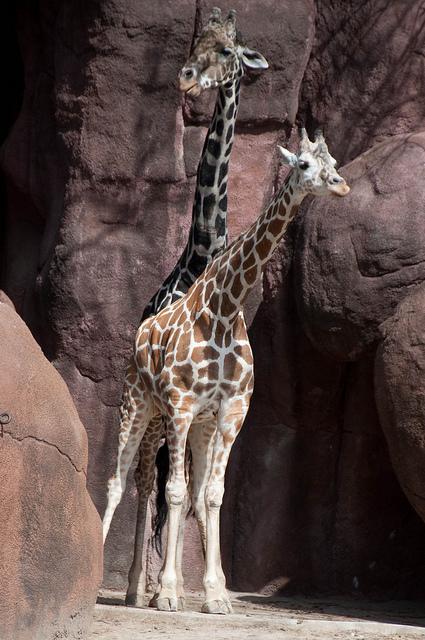What is the giraffe doing?
Answer briefly. Standing. Is the giraffe relaxing?
Be succinct. Yes. Are the giraffes happy?
Keep it brief. Yes. How many giraffes are there?
Answer briefly. 2. How many animals are in this picture?
Concise answer only. 2. Are the elephants in a enclosure?
Be succinct. No. Does this giraffe need to gain some weight?
Keep it brief. No. What kind of animal is in this picture?
Be succinct. Giraffe. Is the giraffe in heat?
Give a very brief answer. No. 